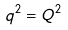Convert formula to latex. <formula><loc_0><loc_0><loc_500><loc_500>q ^ { 2 } = Q ^ { 2 }</formula> 